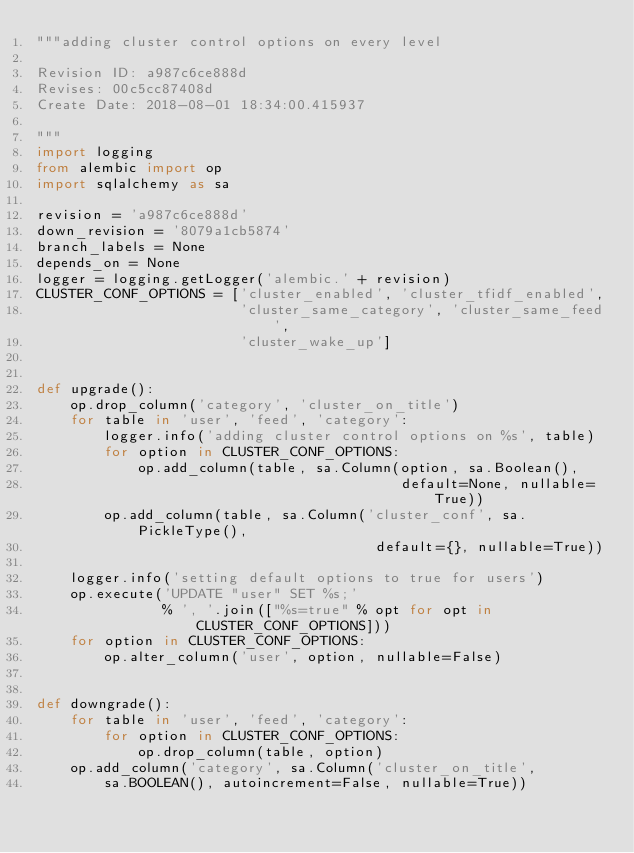<code> <loc_0><loc_0><loc_500><loc_500><_Python_>"""adding cluster control options on every level

Revision ID: a987c6ce888d
Revises: 00c5cc87408d
Create Date: 2018-08-01 18:34:00.415937

"""
import logging
from alembic import op
import sqlalchemy as sa

revision = 'a987c6ce888d'
down_revision = '8079a1cb5874'
branch_labels = None
depends_on = None
logger = logging.getLogger('alembic.' + revision)
CLUSTER_CONF_OPTIONS = ['cluster_enabled', 'cluster_tfidf_enabled',
                        'cluster_same_category', 'cluster_same_feed',
                        'cluster_wake_up']


def upgrade():
    op.drop_column('category', 'cluster_on_title')
    for table in 'user', 'feed', 'category':
        logger.info('adding cluster control options on %s', table)
        for option in CLUSTER_CONF_OPTIONS:
            op.add_column(table, sa.Column(option, sa.Boolean(),
                                           default=None, nullable=True))
        op.add_column(table, sa.Column('cluster_conf', sa.PickleType(),
                                        default={}, nullable=True))

    logger.info('setting default options to true for users')
    op.execute('UPDATE "user" SET %s;'
               % ', '.join(["%s=true" % opt for opt in CLUSTER_CONF_OPTIONS]))
    for option in CLUSTER_CONF_OPTIONS:
        op.alter_column('user', option, nullable=False)


def downgrade():
    for table in 'user', 'feed', 'category':
        for option in CLUSTER_CONF_OPTIONS:
            op.drop_column(table, option)
    op.add_column('category', sa.Column('cluster_on_title',
        sa.BOOLEAN(), autoincrement=False, nullable=True))
</code> 